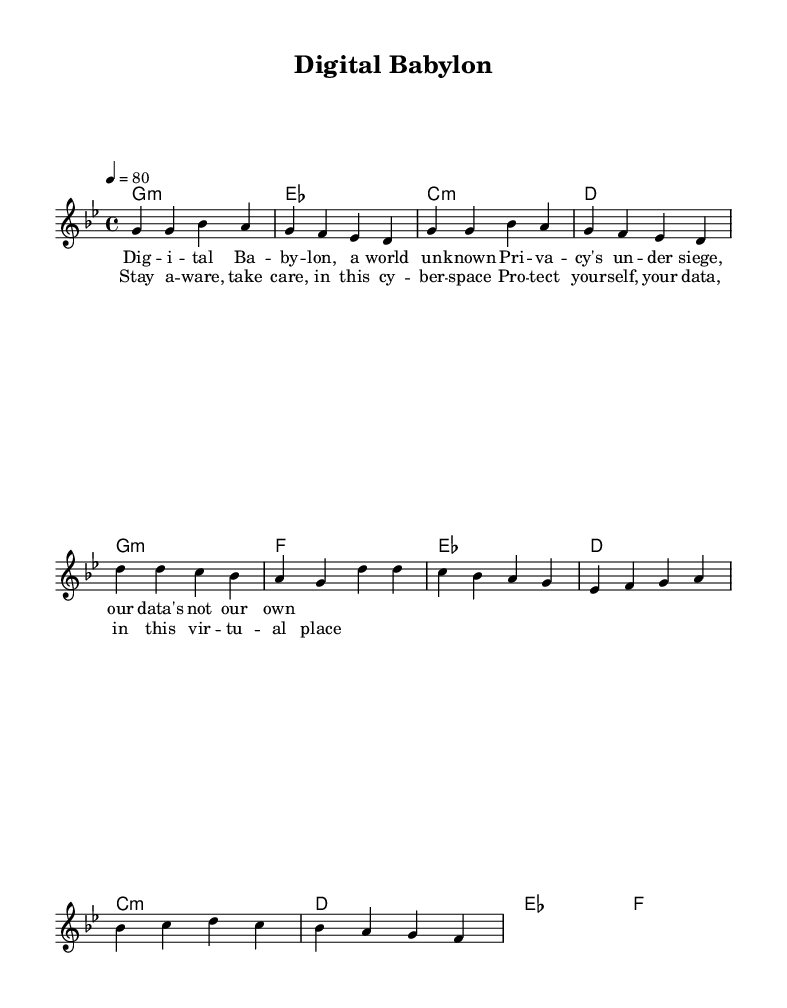What is the key signature of this music? The key signature is G minor, which has two flats (B♭ and E♭). It is indicated by the key signature at the beginning of the staff.
Answer: G minor What is the time signature of this piece? The time signature is 4/4, meaning there are four beats in a measure and a quarter note receives one beat. This is indicated at the beginning of the score.
Answer: 4/4 What is the tempo marking of the piece? The tempo marking is indicated as 4 = 80, which means the quarter note is played at 80 beats per minute. This provides a clear guide for the speed of the music.
Answer: 80 What chords are used in the chorus? The chords used in the chorus are G minor, F, E♭, and D. These can be identified in the chord section corresponding to the chorus lyrics.
Answer: G minor, F, E flat, D How many measures does the bridge contain? The bridge contains four measures, as indicated by the notation provided in the melody section. Each grouping of notes separated by vertical lines corresponds to one measure.
Answer: 4 What thematic issue does this reggae song address? The thematic issue addressed in the song is digital privacy, which can be inferred from the lyrics discussing data ownership and protection in cyberspace.
Answer: Digital privacy What is the title of this reggae song? The title of the song is "Digital Babylon," as indicated in the header section of the sheet music.
Answer: Digital Babylon 